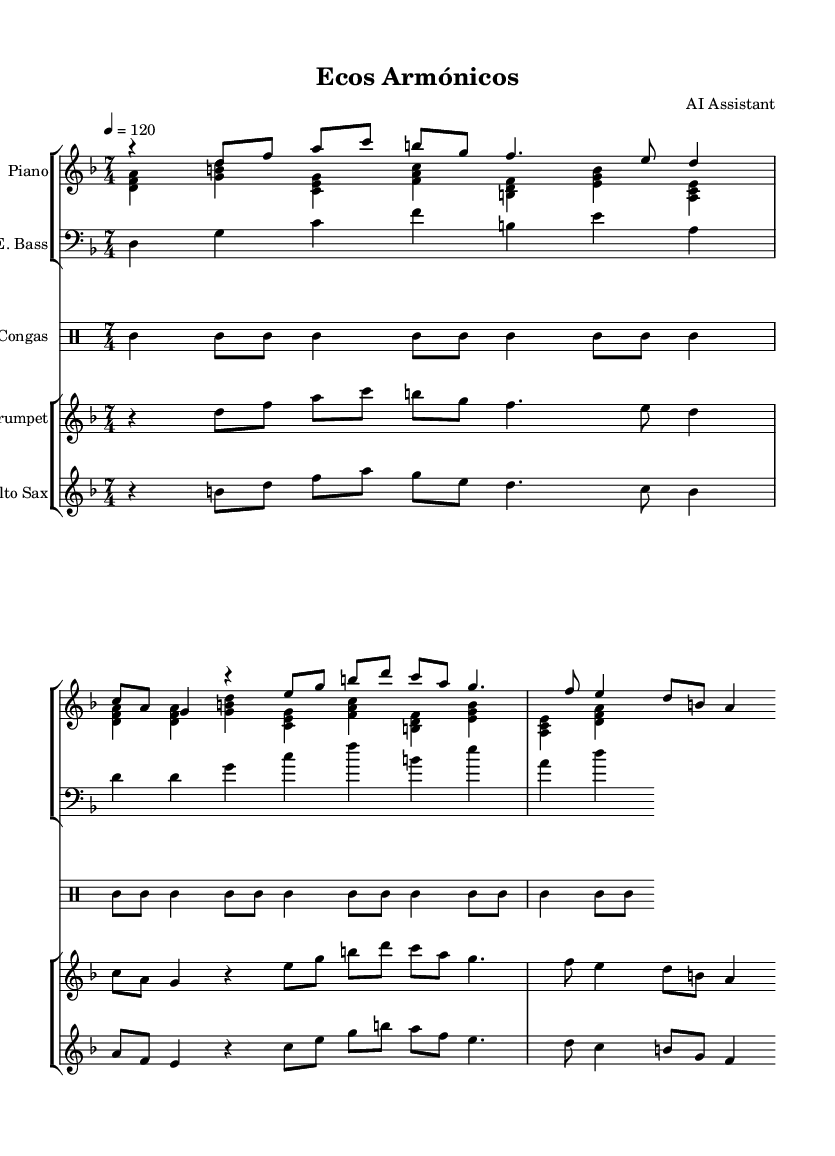What is the key signature of this music? The key signature is indicated by the number of sharps or flats next to the clef at the beginning of the staff. Here, there are no sharps or flats, indicating that it is in D minor, which has a key signature of one flat.
Answer: D minor What is the time signature of this music? The time signature is found at the beginning of the staff after the key signature, represented by two numbers. In this sheet music, the time signature shows 7/4, meaning there are seven quarter note beats in each measure.
Answer: 7/4 What is the tempo marking? The tempo marking is typically located above the staff or at the beginning of the music. Here, it is marked as 4 = 120, indicating the quarter note should be played at 120 beats per minute.
Answer: 120 How many instruments are present in the score? To find the number of instruments, count the different staves present in the score. There are two groups of staves: one for the piano and electric bass and another for the trumpet and alto saxophone, making four instruments in total.
Answer: 4 What is the rhythmic pattern of the Congas section? The rhythmic pattern can be determined by looking at the drum staff and observing the placements of the notes. The pattern is consistent with alternating strikes, creating a lively feel typical in Latin music, particularly with eighth and quarter notes.
Answer: alternating strikes Which instrument plays the highest notes? To determine which instrument plays the highest notes, examine the ranges of each instrument shown in the score. The trumpet generally plays higher than the alto saxophone and both piano voices, making it the highest.
Answer: Trumpet What type of harmony is primarily used in this piece? The harmony can be analyzed based on the chord structures shown in the bass and piano parts. The piece employs complex harmonic structures typical of jazz fusion, characterized by extended chords and interactions between major and minor tonalities.
Answer: Complex harmonic structures 